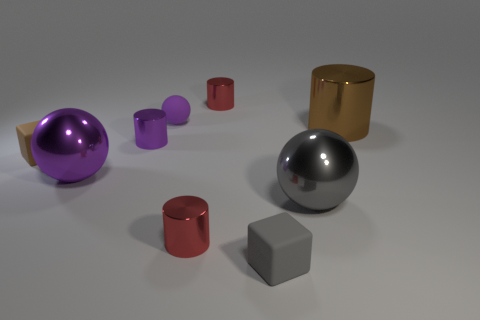What number of other things are the same size as the gray shiny object?
Your answer should be very brief. 2. What number of objects are small red things behind the brown shiny cylinder or shiny cylinders to the right of the tiny purple metal object?
Your answer should be very brief. 3. What number of other small brown objects have the same shape as the tiny brown matte thing?
Make the answer very short. 0. There is a object that is both to the right of the tiny purple rubber sphere and behind the big brown cylinder; what material is it?
Give a very brief answer. Metal. What number of small cubes are left of the brown metallic thing?
Make the answer very short. 2. What number of brown blocks are there?
Your answer should be very brief. 1. Do the matte ball and the brown shiny thing have the same size?
Provide a short and direct response. No. Are there any small purple cylinders on the right side of the small purple cylinder that is on the right side of the brown object left of the small purple ball?
Keep it short and to the point. No. What material is the gray thing that is the same shape as the purple rubber thing?
Your answer should be very brief. Metal. What is the color of the rubber block that is to the left of the tiny gray block?
Keep it short and to the point. Brown. 